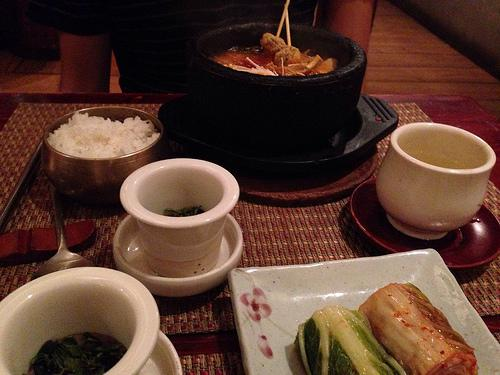Question: what is on the table?
Choices:
A. Flowers.
B. Food.
C. Papers.
D. A baby.
Answer with the letter. Answer: B Question: how is the photo?
Choices:
A. Dark.
B. Blurry.
C. Clear.
D. Over exposed.
Answer with the letter. Answer: C Question: who is in the photo?
Choices:
A. Two people.
B. A person.
C. Four people.
D. Five animals.
Answer with the letter. Answer: B Question: what is in the bowl?
Choices:
A. Noodles.
B. Crackers.
C. Rice.
D. Cookies.
Answer with the letter. Answer: C 